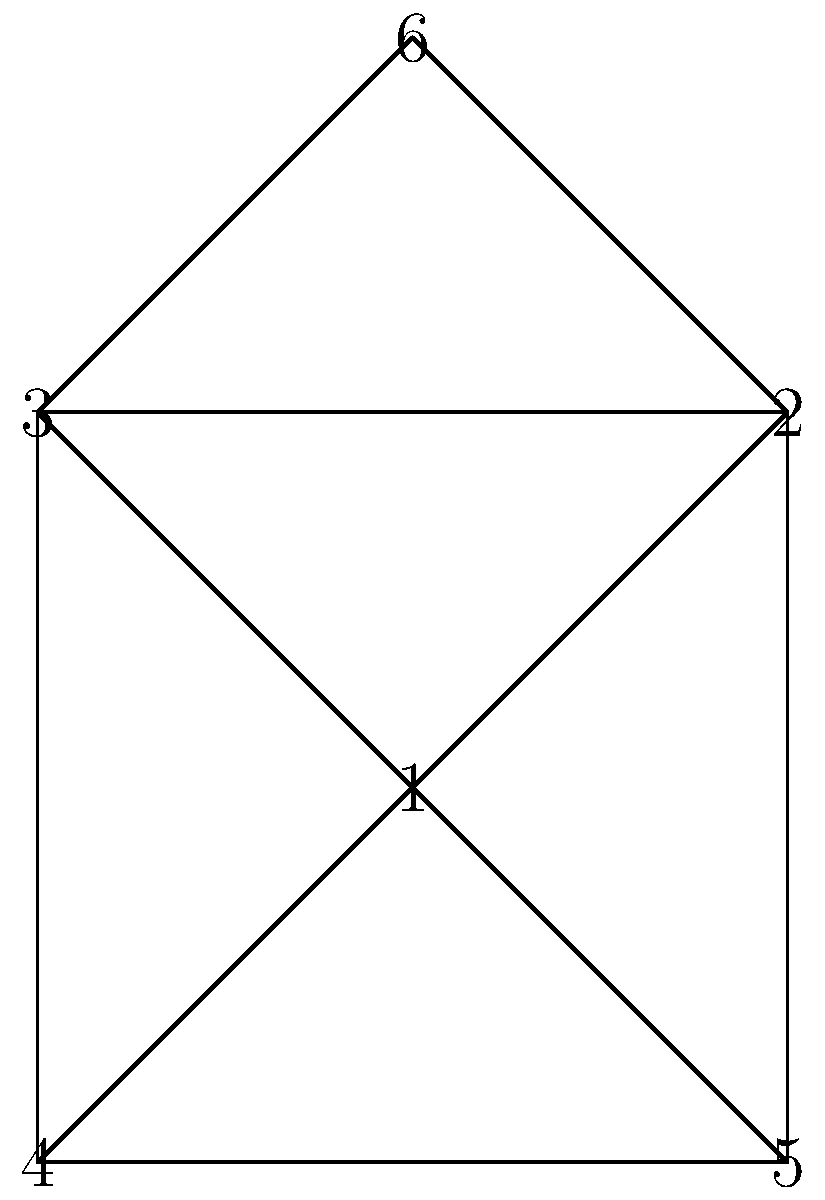In the prison social network represented by the graph above, each node represents an inmate and each edge represents a social connection. What is the degree of node 1, and what does this indicate about the inmate's social status within the prison environment? To solve this problem, we need to follow these steps:

1. Understand the concept of degree in graph theory:
   - The degree of a node is the number of edges connected to it.

2. Count the number of edges connected to node 1:
   - Node 1 is connected to nodes 2, 3, 4, and 5.
   - There are 4 edges connected to node 1.

3. Interpret the meaning of the degree in the context of the prison social network:
   - A higher degree indicates more social connections.
   - More connections often suggest a more influential or central position in the social network.

4. Consider the implications of having a high degree in a prison environment:
   - The inmate represented by node 1 has many social connections.
   - This could indicate that the inmate is well-known, influential, or has been in the prison for a longer time.
   - However, it's important to note that more connections don't always mean positive influence; they could also indicate involvement in various prison activities or groups.

Therefore, the degree of node 1 is 4, suggesting that the inmate has a significant number of social connections and potentially holds an important position in the prison's social structure.
Answer: Degree: 4; Indicates potentially influential social status. 